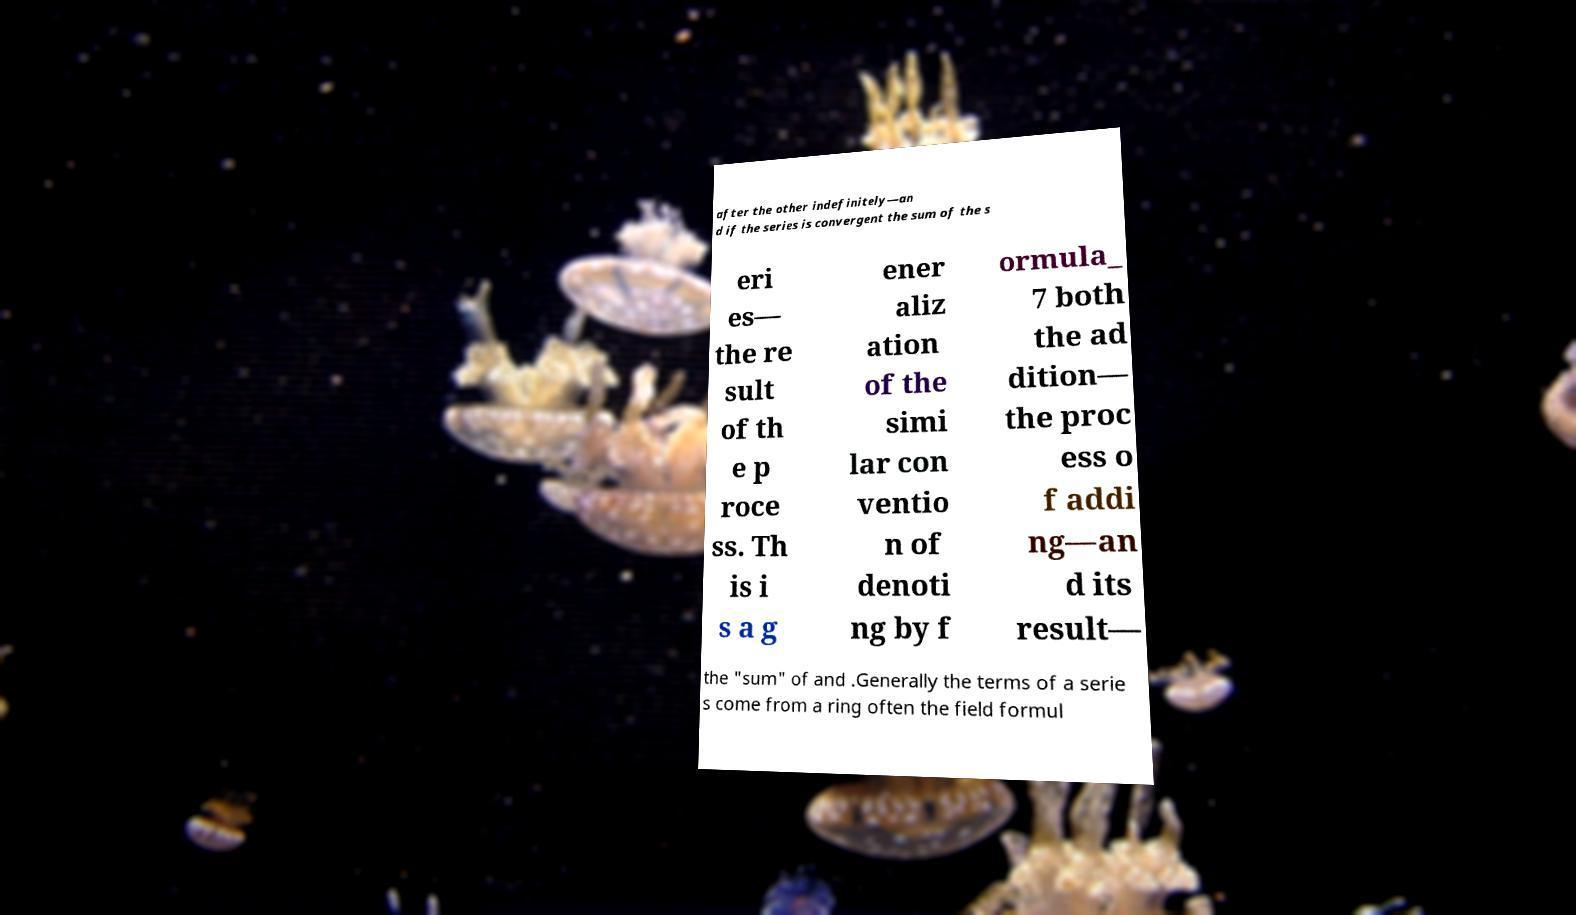For documentation purposes, I need the text within this image transcribed. Could you provide that? after the other indefinitely—an d if the series is convergent the sum of the s eri es— the re sult of th e p roce ss. Th is i s a g ener aliz ation of the simi lar con ventio n of denoti ng by f ormula_ 7 both the ad dition— the proc ess o f addi ng—an d its result— the "sum" of and .Generally the terms of a serie s come from a ring often the field formul 